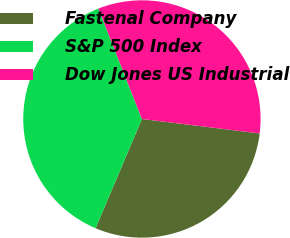Convert chart to OTSL. <chart><loc_0><loc_0><loc_500><loc_500><pie_chart><fcel>Fastenal Company<fcel>S&P 500 Index<fcel>Dow Jones US Industrial<nl><fcel>29.44%<fcel>37.64%<fcel>32.91%<nl></chart> 